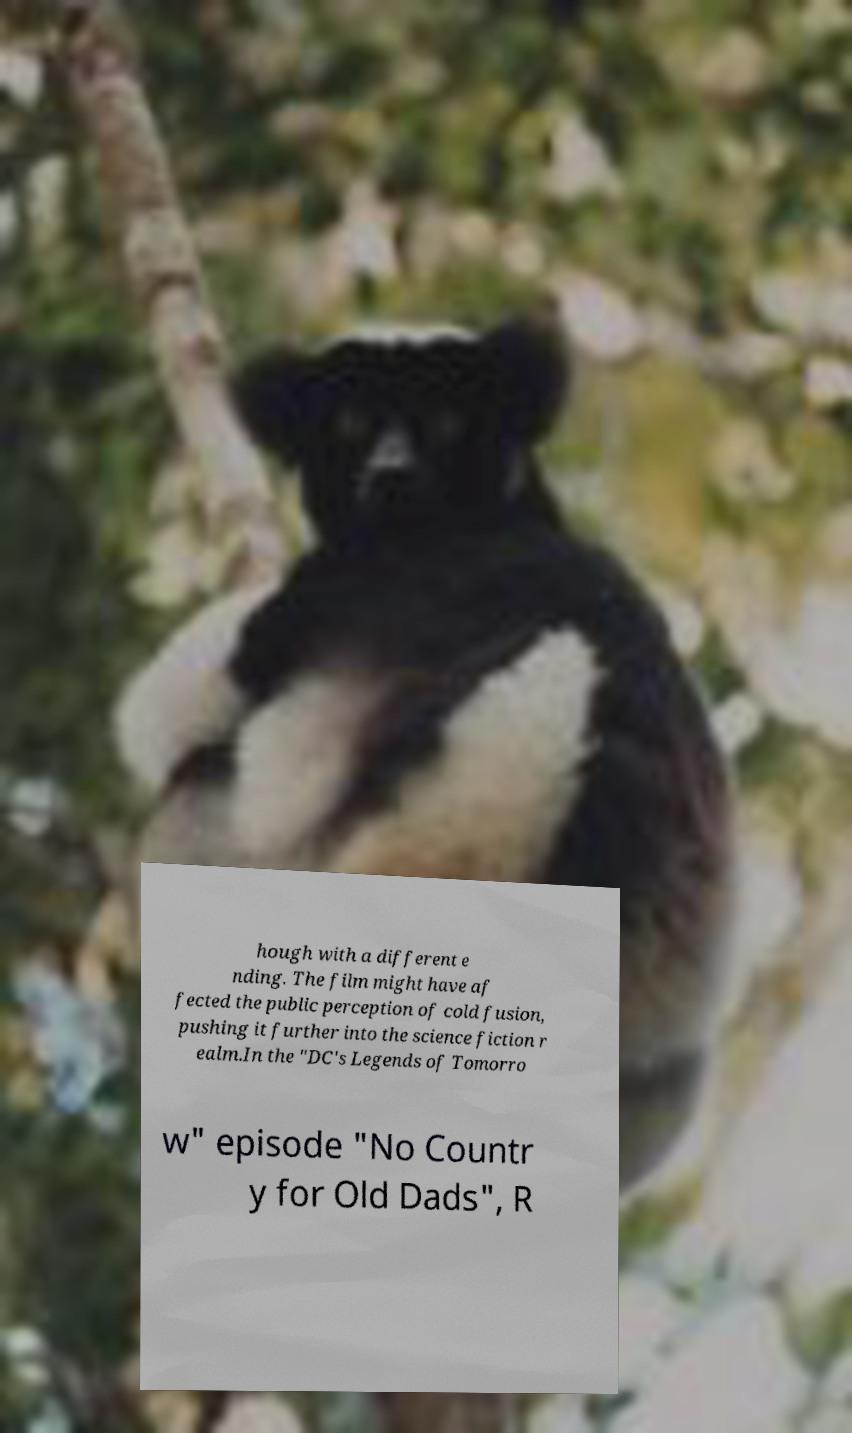Please read and relay the text visible in this image. What does it say? hough with a different e nding. The film might have af fected the public perception of cold fusion, pushing it further into the science fiction r ealm.In the "DC's Legends of Tomorro w" episode "No Countr y for Old Dads", R 